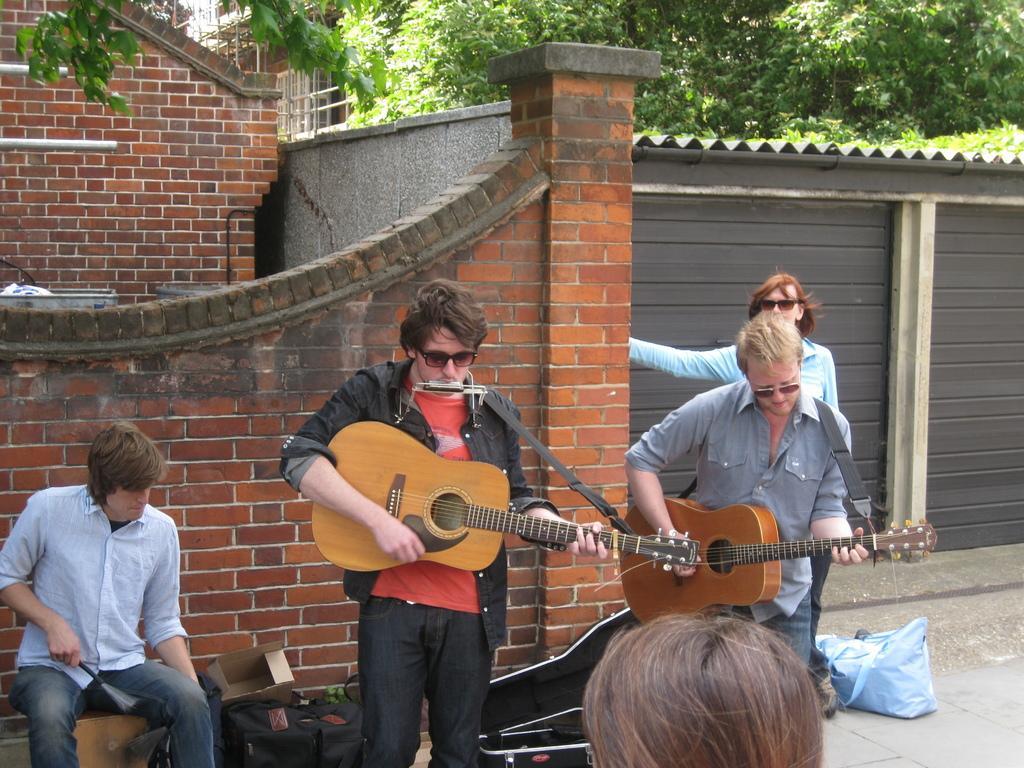In one or two sentences, can you explain what this image depicts? This image is taken in outdoors. In the left side of the image there is a person sitting on a stool. In this image there are five people. In the right side of the image there is a shutter. In the middle of the image there is a person standing holding a guitar in his hands. At the background there is a brick wall and a house. At the top of the image there are few trees. 